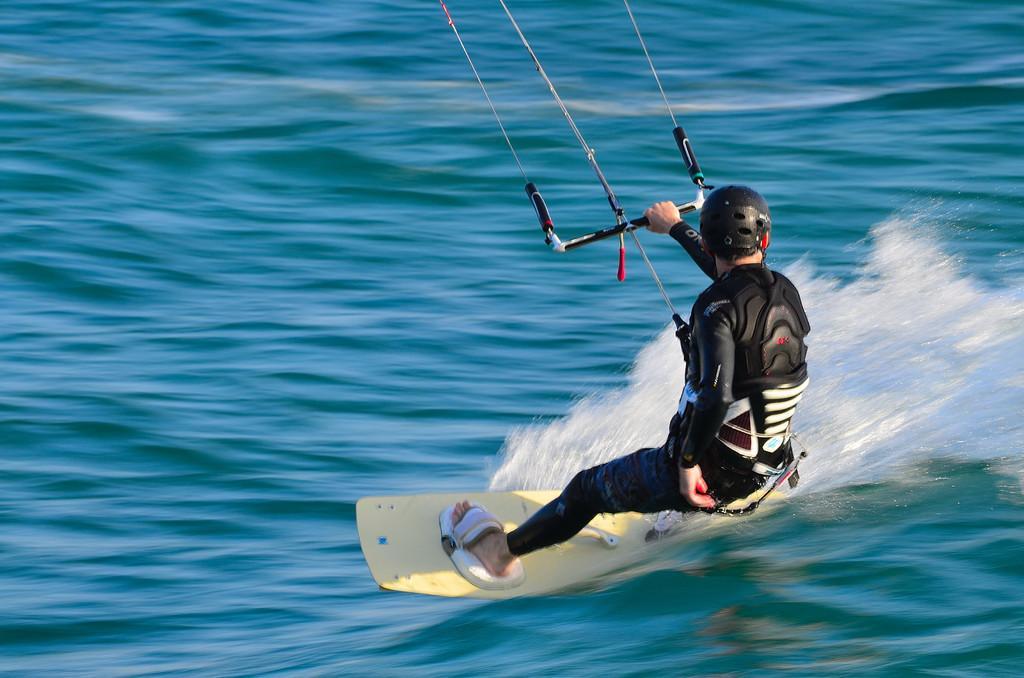Please provide a concise description of this image. In the center of the image there is a person wearing a black color uniform and surfing in water. 